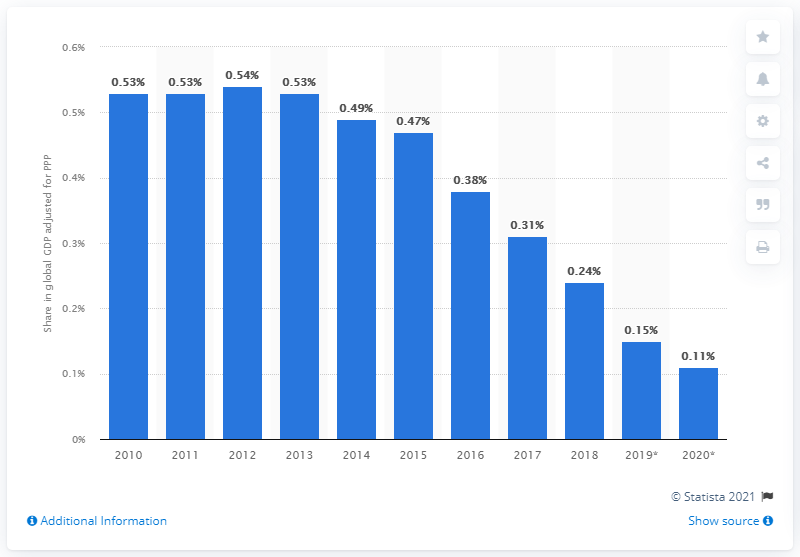Give some essential details in this illustration. Venezuela's share of the global gross domestic product, adjusted for purchasing power parity in 2018, was 0.24%. 